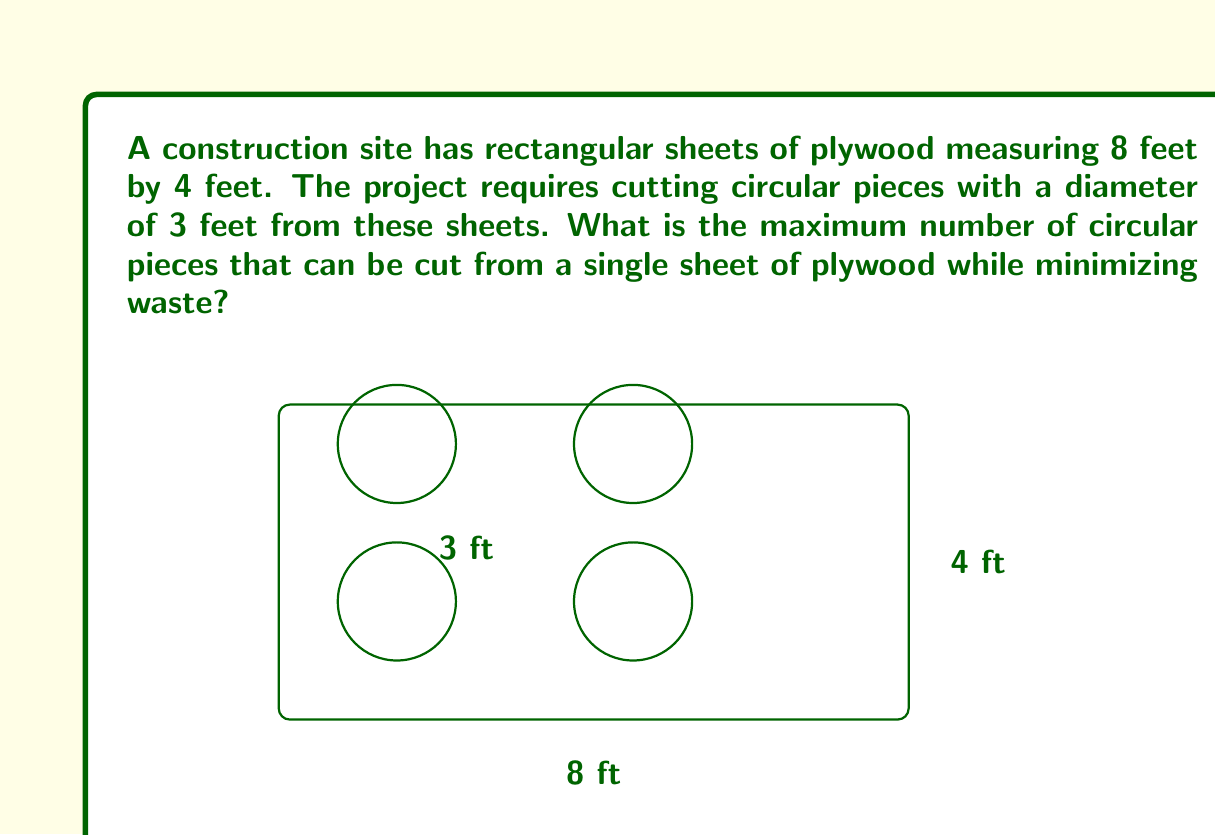Show me your answer to this math problem. To solve this problem, we need to consider the most efficient arrangement of circular pieces within the rectangular sheet. Let's approach this step-by-step:

1) First, let's convert all measurements to feet:
   Sheet dimensions: 8 ft × 4 ft
   Circular piece diameter: 3 ft

2) The area of the circular piece:
   $A_circle = \pi r^2 = \pi (1.5)^2 = 2.25\pi$ sq ft

3) The area of the plywood sheet:
   $A_sheet = 8 \times 4 = 32$ sq ft

4) Theoretically, the maximum number of circles would be:
   $\frac{A_sheet}{A_circle} = \frac{32}{2.25\pi} \approx 4.5$

   However, we can't cut partial circles, so we need to consider the actual arrangement.

5) The most efficient arrangement is to place the circles in two rows:
   - Along the 8 ft side, we can fit 2 circles with 1 ft space between them and the edges
   - Along the 4 ft side, we can fit 2 circles with 0.5 ft space between them and the edges

6) This arrangement allows for 4 complete circles to be cut from the sheet.

7) To verify, let's calculate the waste:
   - Area of 4 circles: $4 \times 2.25\pi = 9\pi$ sq ft
   - Area of sheet: 32 sq ft
   - Waste area: $32 - 9\pi \approx 3.73$ sq ft

This arrangement minimizes waste while maximizing the number of whole circles that can be cut.
Answer: 4 circular pieces 